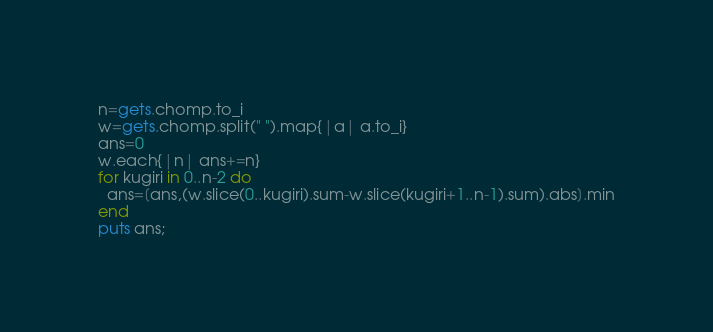<code> <loc_0><loc_0><loc_500><loc_500><_Ruby_>n=gets.chomp.to_i
w=gets.chomp.split(" ").map{|a| a.to_i}
ans=0
w.each{|n| ans+=n}
for kugiri in 0..n-2 do
  ans=[ans,(w.slice(0..kugiri).sum-w.slice(kugiri+1..n-1).sum).abs].min
end
puts ans;</code> 